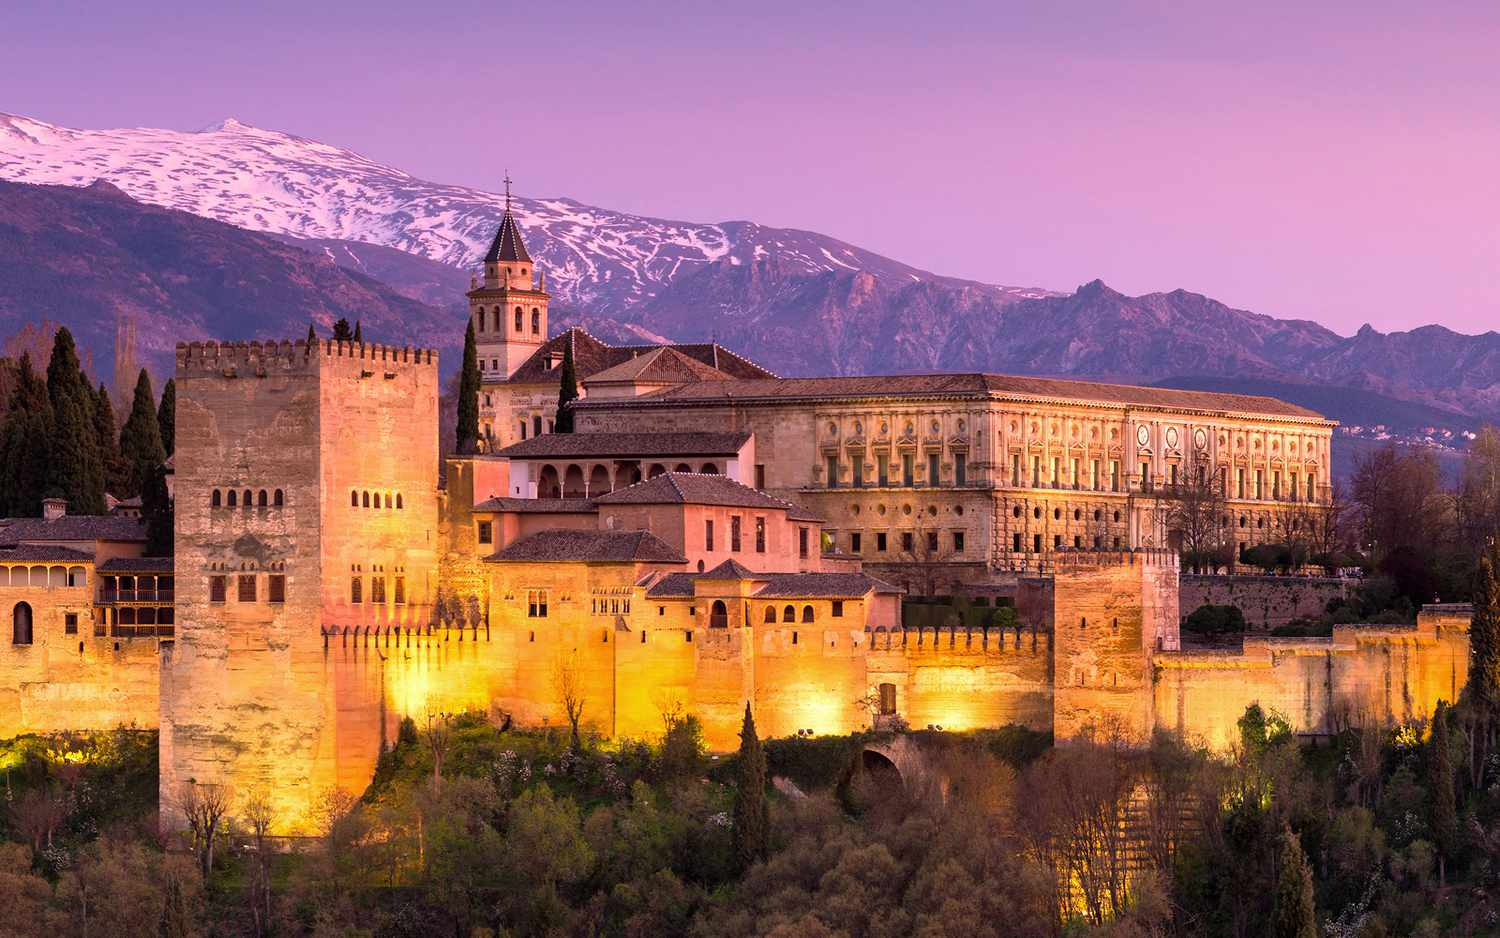What is the significance of the lighting in this photograph? The lighting in this photograph is not only visually stunning but also symbolic. The warmth of the artificial lights illuminating the Alhambra endows the scene with a kind of ethereal beauty and serves to highlight the intricate details of the fortress's architecture. It suggests the vibrancy of life that has pulsed through its walls for centuries. Additionally, the contrast created by the setting sun casts a serene and somewhat surreal ambiance over the entire scene, inviting reflection on the passage of time and the enduring magnificence of this historic monument. 